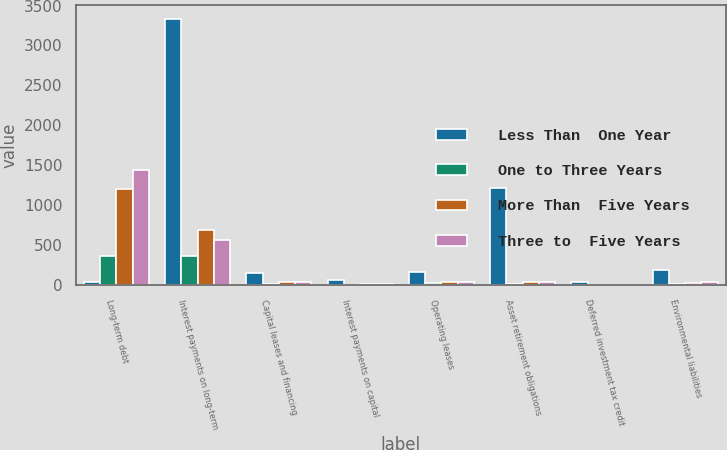Convert chart. <chart><loc_0><loc_0><loc_500><loc_500><stacked_bar_chart><ecel><fcel>Long-term debt<fcel>Interest payments on long-term<fcel>Capital leases and financing<fcel>Interest payments on capital<fcel>Operating leases<fcel>Asset retirement obligations<fcel>Deferred investment tax credit<fcel>Environmental liabilities<nl><fcel>Less Than  One Year<fcel>38<fcel>3335<fcel>159<fcel>64<fcel>164<fcel>1215<fcel>40<fcel>198<nl><fcel>One to Three Years<fcel>368<fcel>364<fcel>23<fcel>10<fcel>26<fcel>11<fcel>3<fcel>14<nl><fcel>More Than  Five Years<fcel>1207<fcel>694<fcel>43<fcel>17<fcel>45<fcel>37<fcel>6<fcel>34<nl><fcel>Three to  Five Years<fcel>1443<fcel>573<fcel>38<fcel>15<fcel>37<fcel>36<fcel>5<fcel>36<nl></chart> 